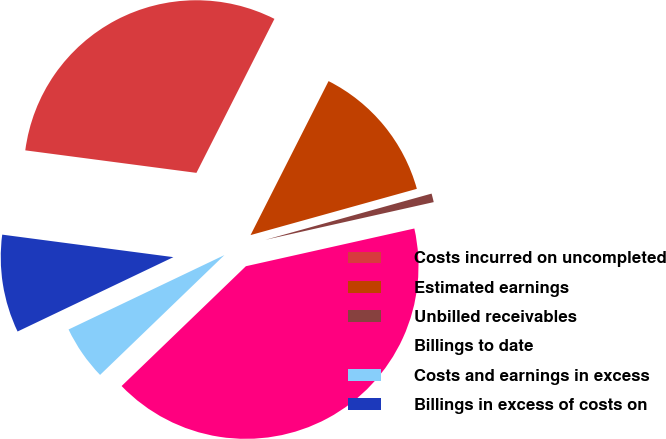<chart> <loc_0><loc_0><loc_500><loc_500><pie_chart><fcel>Costs incurred on uncompleted<fcel>Estimated earnings<fcel>Unbilled receivables<fcel>Billings to date<fcel>Costs and earnings in excess<fcel>Billings in excess of costs on<nl><fcel>30.38%<fcel>13.22%<fcel>0.81%<fcel>41.3%<fcel>5.12%<fcel>9.17%<nl></chart> 